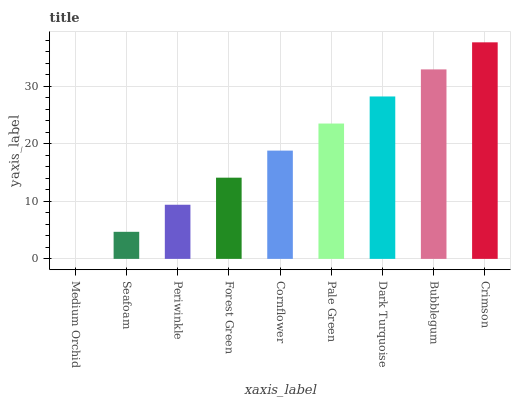Is Medium Orchid the minimum?
Answer yes or no. Yes. Is Crimson the maximum?
Answer yes or no. Yes. Is Seafoam the minimum?
Answer yes or no. No. Is Seafoam the maximum?
Answer yes or no. No. Is Seafoam greater than Medium Orchid?
Answer yes or no. Yes. Is Medium Orchid less than Seafoam?
Answer yes or no. Yes. Is Medium Orchid greater than Seafoam?
Answer yes or no. No. Is Seafoam less than Medium Orchid?
Answer yes or no. No. Is Cornflower the high median?
Answer yes or no. Yes. Is Cornflower the low median?
Answer yes or no. Yes. Is Bubblegum the high median?
Answer yes or no. No. Is Seafoam the low median?
Answer yes or no. No. 